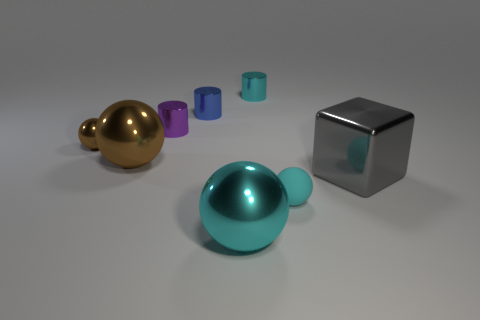Is the color of the large sphere that is on the right side of the large brown object the same as the matte object?
Provide a succinct answer. Yes. There is a cylinder that is the same color as the small rubber sphere; what is it made of?
Your answer should be very brief. Metal. There is a blue thing that is the same size as the purple cylinder; what is its material?
Make the answer very short. Metal. Is there a blue cylinder of the same size as the metallic cube?
Make the answer very short. No. What is the shape of the cyan metallic object that is the same size as the blue object?
Ensure brevity in your answer.  Cylinder. How many other objects are the same color as the matte thing?
Keep it short and to the point. 2. The large shiny thing that is both behind the tiny matte object and to the right of the big brown thing has what shape?
Offer a terse response. Cube. Is there a tiny brown shiny thing that is behind the small object on the left side of the brown thing right of the tiny brown shiny sphere?
Provide a succinct answer. No. What number of other things are there of the same material as the big gray block
Offer a very short reply. 6. How many small rubber things are there?
Your response must be concise. 1. 